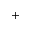Convert formula to latex. <formula><loc_0><loc_0><loc_500><loc_500>^ { + }</formula> 